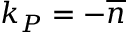Convert formula to latex. <formula><loc_0><loc_0><loc_500><loc_500>k _ { P } = - \overline { n }</formula> 